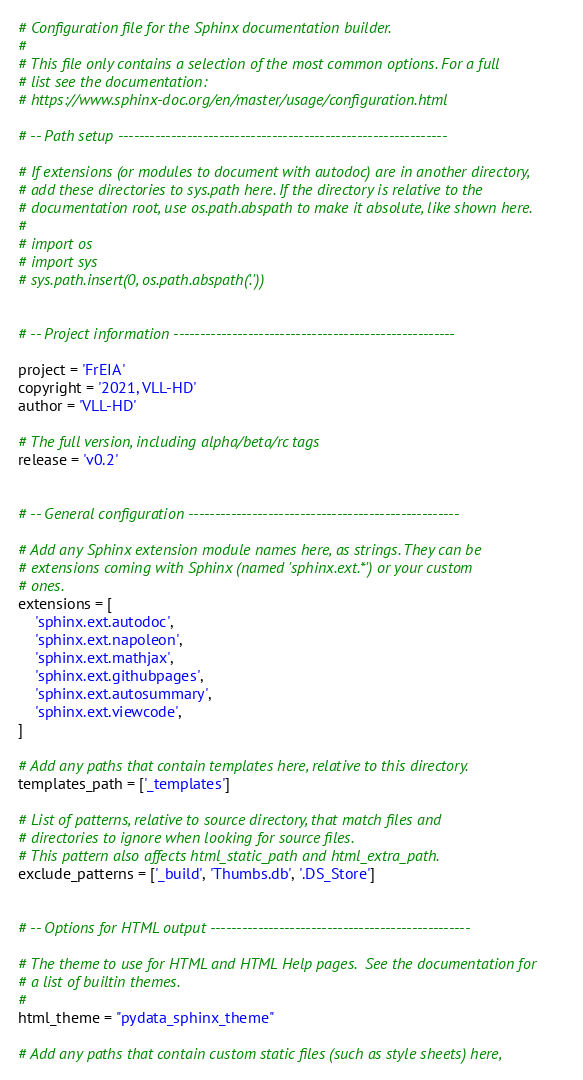Convert code to text. <code><loc_0><loc_0><loc_500><loc_500><_Python_># Configuration file for the Sphinx documentation builder.
#
# This file only contains a selection of the most common options. For a full
# list see the documentation:
# https://www.sphinx-doc.org/en/master/usage/configuration.html

# -- Path setup --------------------------------------------------------------

# If extensions (or modules to document with autodoc) are in another directory,
# add these directories to sys.path here. If the directory is relative to the
# documentation root, use os.path.abspath to make it absolute, like shown here.
#
# import os
# import sys
# sys.path.insert(0, os.path.abspath('.'))


# -- Project information -----------------------------------------------------

project = 'FrEIA'
copyright = '2021, VLL-HD'
author = 'VLL-HD'

# The full version, including alpha/beta/rc tags
release = 'v0.2'


# -- General configuration ---------------------------------------------------

# Add any Sphinx extension module names here, as strings. They can be
# extensions coming with Sphinx (named 'sphinx.ext.*') or your custom
# ones.
extensions = [
    'sphinx.ext.autodoc',
    'sphinx.ext.napoleon',
    'sphinx.ext.mathjax',
    'sphinx.ext.githubpages',
    'sphinx.ext.autosummary',
    'sphinx.ext.viewcode',
]

# Add any paths that contain templates here, relative to this directory.
templates_path = ['_templates']

# List of patterns, relative to source directory, that match files and
# directories to ignore when looking for source files.
# This pattern also affects html_static_path and html_extra_path.
exclude_patterns = ['_build', 'Thumbs.db', '.DS_Store']


# -- Options for HTML output -------------------------------------------------

# The theme to use for HTML and HTML Help pages.  See the documentation for
# a list of builtin themes.
#
html_theme = "pydata_sphinx_theme"

# Add any paths that contain custom static files (such as style sheets) here,</code> 